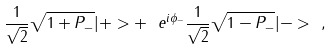Convert formula to latex. <formula><loc_0><loc_0><loc_500><loc_500>\frac { 1 } { \sqrt { 2 } } \sqrt { 1 + P _ { - } } | + > + \ e ^ { i \phi _ { - } } \frac { 1 } { \sqrt { 2 } } \sqrt { 1 - P _ { - } } | - > \ ,</formula> 